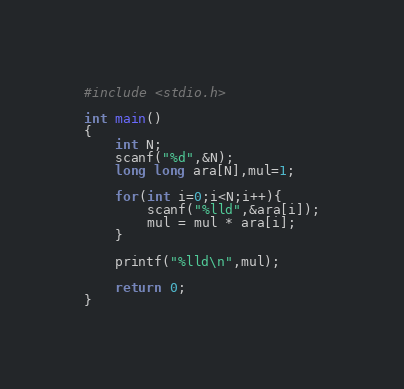Convert code to text. <code><loc_0><loc_0><loc_500><loc_500><_C_>#include <stdio.h>

int main()
{
    int N;
    scanf("%d",&N);
    long long ara[N],mul=1;

    for(int i=0;i<N;i++){
        scanf("%lld",&ara[i]);
        mul = mul * ara[i];
    }

    printf("%lld\n",mul);

    return 0;
}
</code> 